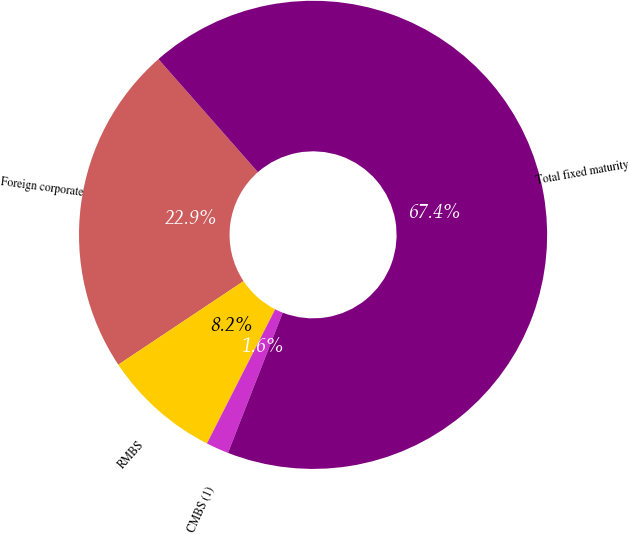Convert chart. <chart><loc_0><loc_0><loc_500><loc_500><pie_chart><fcel>Foreign corporate<fcel>RMBS<fcel>CMBS (1)<fcel>Total fixed maturity<nl><fcel>22.87%<fcel>8.15%<fcel>1.57%<fcel>67.4%<nl></chart> 